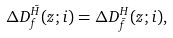<formula> <loc_0><loc_0><loc_500><loc_500>\Delta D _ { f } ^ { \bar { H } } ( z ; i ) = \Delta D _ { \bar { f } } ^ { H } ( z ; i ) ,</formula> 